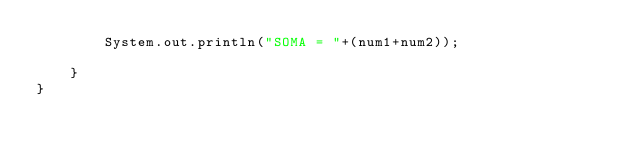Convert code to text. <code><loc_0><loc_0><loc_500><loc_500><_Java_>        System.out.println("SOMA = "+(num1+num2));

    }
}
</code> 